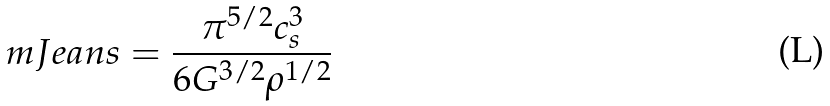<formula> <loc_0><loc_0><loc_500><loc_500>\ m J e a n s = \frac { \pi ^ { 5 / 2 } c _ { s } ^ { 3 } } { 6 G ^ { 3 / 2 } \rho ^ { 1 / 2 } }</formula> 